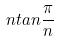<formula> <loc_0><loc_0><loc_500><loc_500>n t a n \frac { \pi } { n }</formula> 